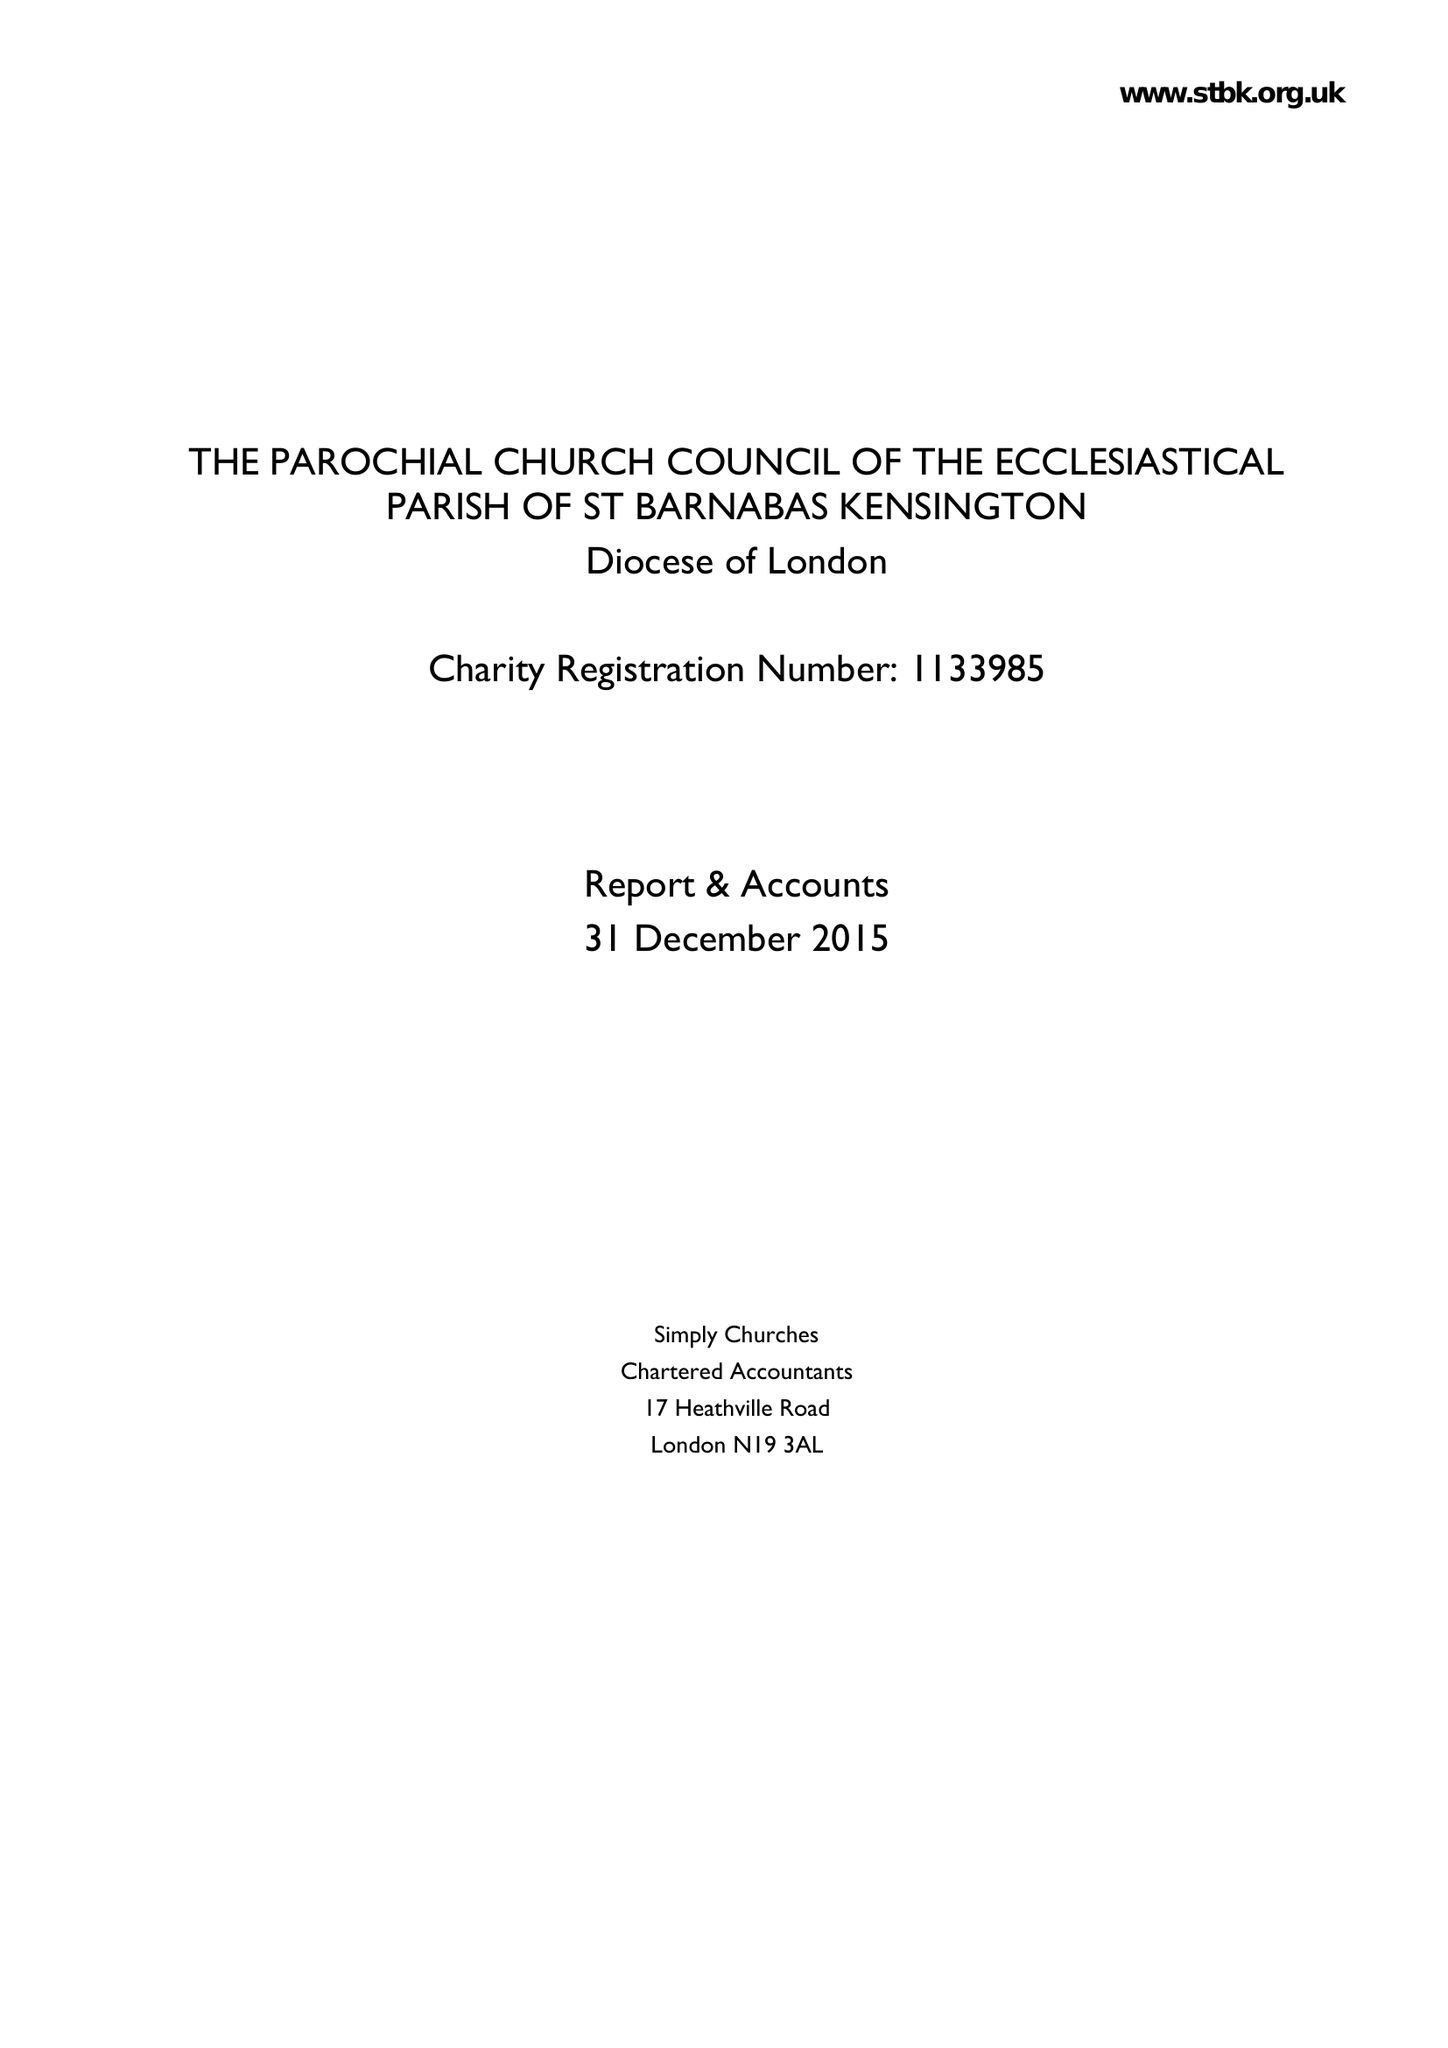What is the value for the address__post_town?
Answer the question using a single word or phrase. LONDON 